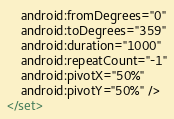<code> <loc_0><loc_0><loc_500><loc_500><_XML_>    android:fromDegrees="0"
    android:toDegrees="359"
    android:duration="1000"
    android:repeatCount="-1"
    android:pivotX="50%"
    android:pivotY="50%" />
</set></code> 